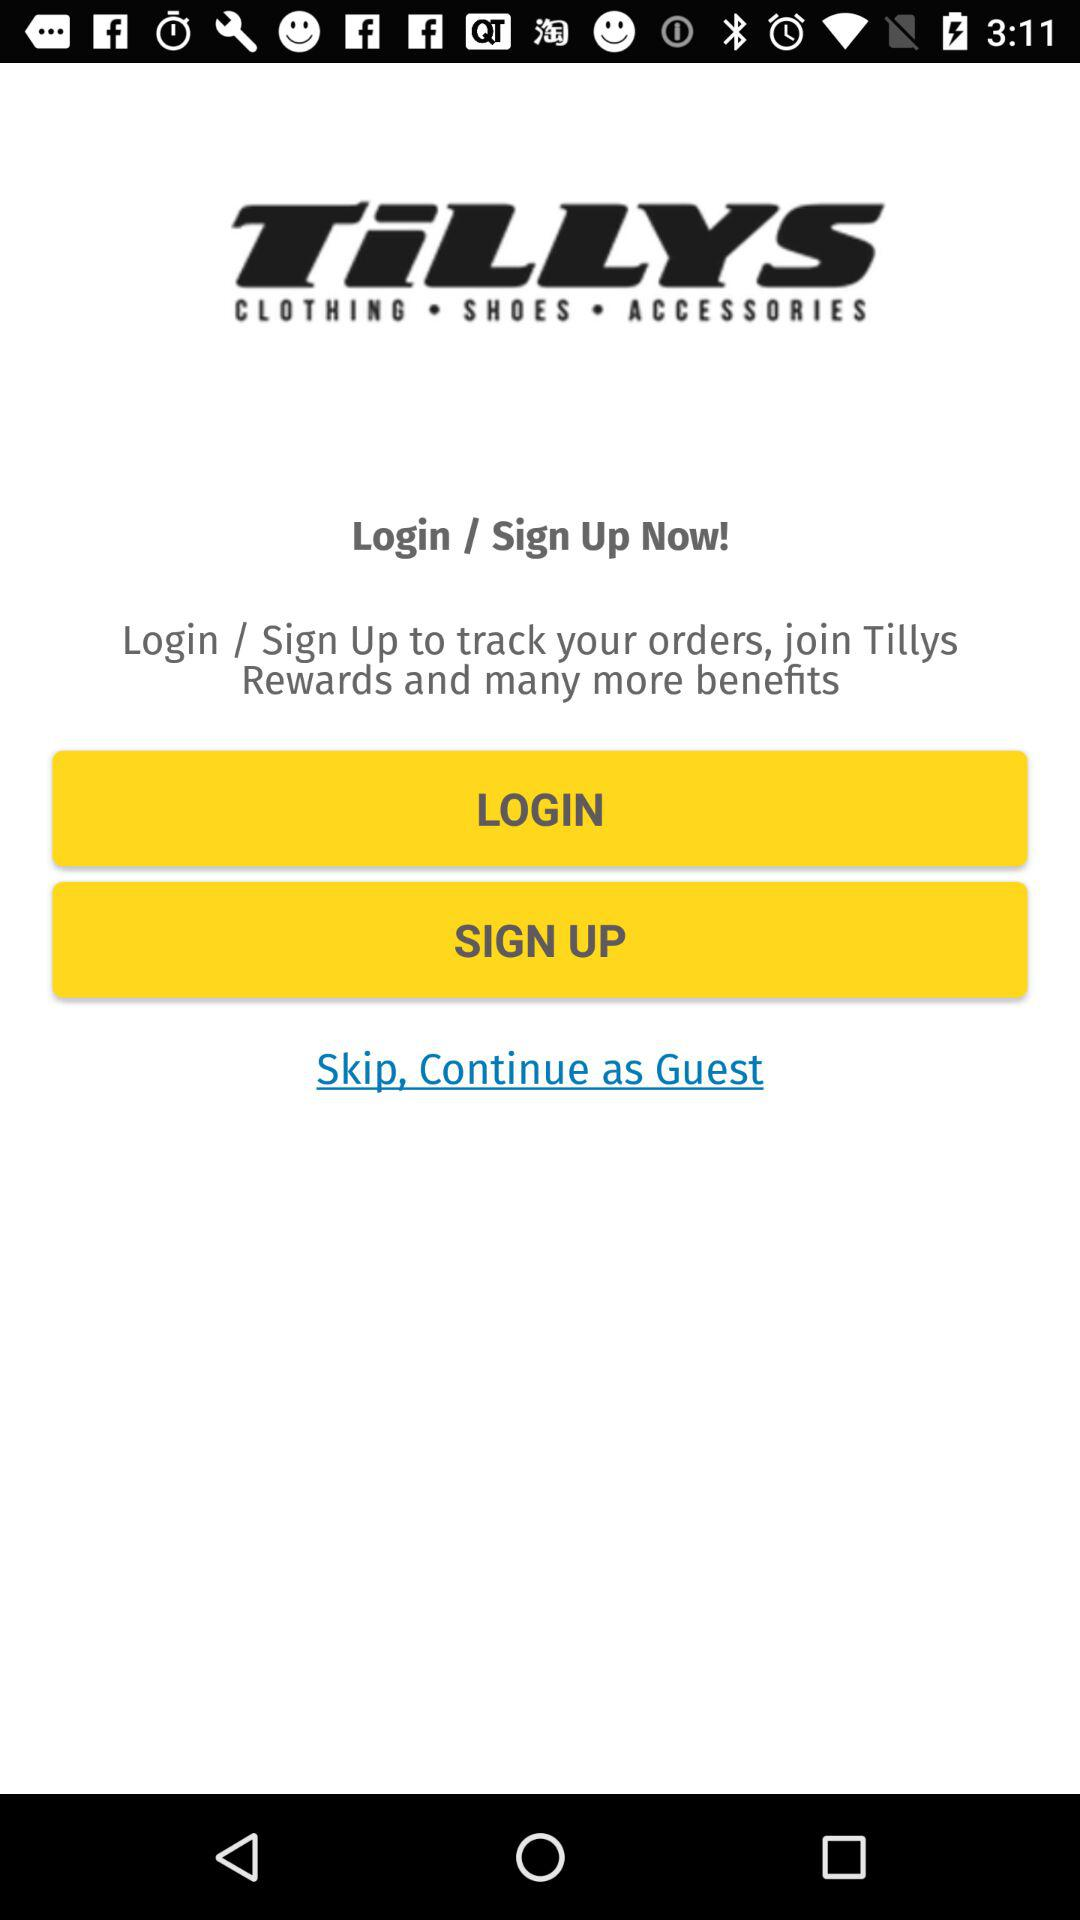Are there any special features or benefits in using the Tillys app? Yes, the Tillys app often provides users with a convenient shopping experience including personalized recommendations based on past purchases. It may also provide app-exclusive discounts, early sale access, and a rewards program where points can be earned and redeemed for discounts on future purchases. Notifications on new arrivals and promotions keep app users updated on the latest offerings. 